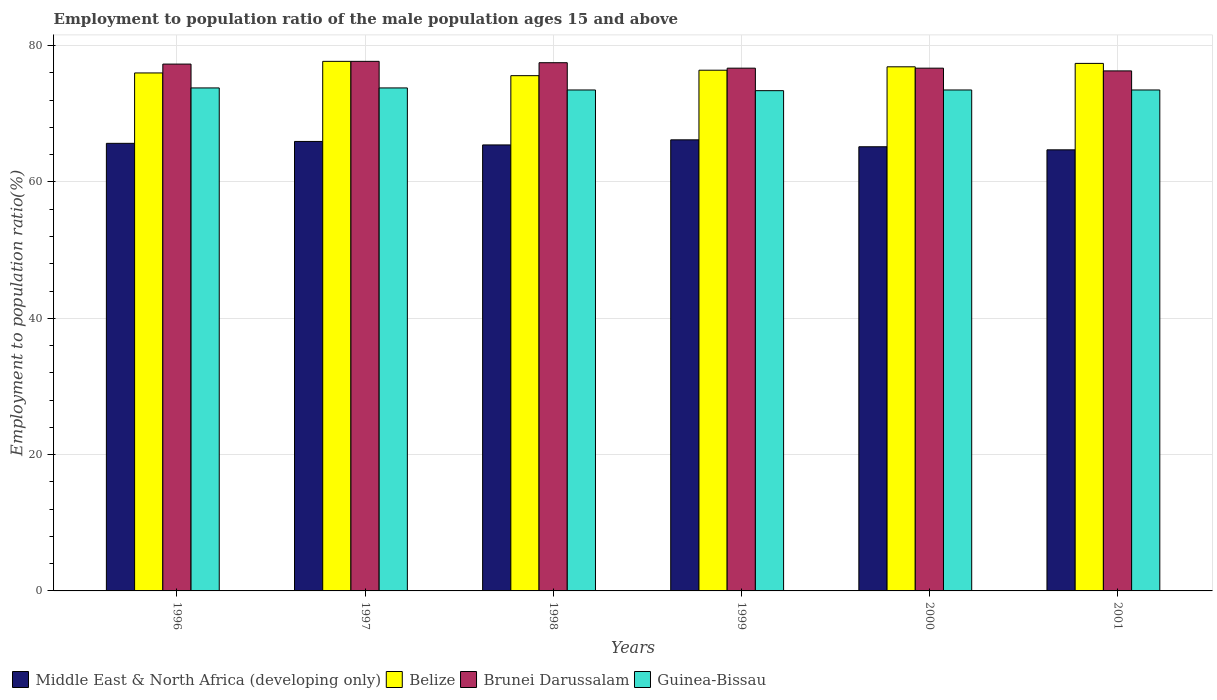How many groups of bars are there?
Keep it short and to the point. 6. How many bars are there on the 1st tick from the left?
Give a very brief answer. 4. In how many cases, is the number of bars for a given year not equal to the number of legend labels?
Keep it short and to the point. 0. What is the employment to population ratio in Belize in 2000?
Your answer should be compact. 76.9. Across all years, what is the maximum employment to population ratio in Middle East & North Africa (developing only)?
Your answer should be very brief. 66.18. Across all years, what is the minimum employment to population ratio in Belize?
Your answer should be very brief. 75.6. In which year was the employment to population ratio in Middle East & North Africa (developing only) maximum?
Provide a succinct answer. 1999. What is the total employment to population ratio in Belize in the graph?
Offer a terse response. 460. What is the difference between the employment to population ratio in Brunei Darussalam in 1997 and the employment to population ratio in Guinea-Bissau in 1998?
Keep it short and to the point. 4.2. What is the average employment to population ratio in Brunei Darussalam per year?
Give a very brief answer. 77.03. In the year 2000, what is the difference between the employment to population ratio in Belize and employment to population ratio in Guinea-Bissau?
Offer a terse response. 3.4. What is the ratio of the employment to population ratio in Middle East & North Africa (developing only) in 1996 to that in 2000?
Give a very brief answer. 1.01. What is the difference between the highest and the lowest employment to population ratio in Brunei Darussalam?
Your answer should be compact. 1.4. Is the sum of the employment to population ratio in Belize in 1997 and 1998 greater than the maximum employment to population ratio in Brunei Darussalam across all years?
Make the answer very short. Yes. What does the 3rd bar from the left in 1997 represents?
Make the answer very short. Brunei Darussalam. What does the 2nd bar from the right in 1999 represents?
Provide a short and direct response. Brunei Darussalam. Is it the case that in every year, the sum of the employment to population ratio in Brunei Darussalam and employment to population ratio in Belize is greater than the employment to population ratio in Middle East & North Africa (developing only)?
Keep it short and to the point. Yes. Are all the bars in the graph horizontal?
Make the answer very short. No. What is the difference between two consecutive major ticks on the Y-axis?
Your response must be concise. 20. Are the values on the major ticks of Y-axis written in scientific E-notation?
Offer a very short reply. No. Does the graph contain grids?
Keep it short and to the point. Yes. How many legend labels are there?
Your answer should be very brief. 4. How are the legend labels stacked?
Keep it short and to the point. Horizontal. What is the title of the graph?
Offer a terse response. Employment to population ratio of the male population ages 15 and above. Does "Guatemala" appear as one of the legend labels in the graph?
Offer a terse response. No. What is the label or title of the X-axis?
Your answer should be very brief. Years. What is the label or title of the Y-axis?
Give a very brief answer. Employment to population ratio(%). What is the Employment to population ratio(%) in Middle East & North Africa (developing only) in 1996?
Ensure brevity in your answer.  65.67. What is the Employment to population ratio(%) in Belize in 1996?
Ensure brevity in your answer.  76. What is the Employment to population ratio(%) in Brunei Darussalam in 1996?
Ensure brevity in your answer.  77.3. What is the Employment to population ratio(%) of Guinea-Bissau in 1996?
Offer a very short reply. 73.8. What is the Employment to population ratio(%) of Middle East & North Africa (developing only) in 1997?
Your response must be concise. 65.95. What is the Employment to population ratio(%) of Belize in 1997?
Provide a short and direct response. 77.7. What is the Employment to population ratio(%) in Brunei Darussalam in 1997?
Provide a succinct answer. 77.7. What is the Employment to population ratio(%) in Guinea-Bissau in 1997?
Your answer should be very brief. 73.8. What is the Employment to population ratio(%) of Middle East & North Africa (developing only) in 1998?
Your answer should be very brief. 65.44. What is the Employment to population ratio(%) of Belize in 1998?
Make the answer very short. 75.6. What is the Employment to population ratio(%) in Brunei Darussalam in 1998?
Make the answer very short. 77.5. What is the Employment to population ratio(%) in Guinea-Bissau in 1998?
Your answer should be compact. 73.5. What is the Employment to population ratio(%) in Middle East & North Africa (developing only) in 1999?
Give a very brief answer. 66.18. What is the Employment to population ratio(%) in Belize in 1999?
Provide a succinct answer. 76.4. What is the Employment to population ratio(%) in Brunei Darussalam in 1999?
Provide a succinct answer. 76.7. What is the Employment to population ratio(%) of Guinea-Bissau in 1999?
Your answer should be very brief. 73.4. What is the Employment to population ratio(%) in Middle East & North Africa (developing only) in 2000?
Your answer should be very brief. 65.17. What is the Employment to population ratio(%) of Belize in 2000?
Give a very brief answer. 76.9. What is the Employment to population ratio(%) in Brunei Darussalam in 2000?
Offer a terse response. 76.7. What is the Employment to population ratio(%) in Guinea-Bissau in 2000?
Keep it short and to the point. 73.5. What is the Employment to population ratio(%) of Middle East & North Africa (developing only) in 2001?
Ensure brevity in your answer.  64.72. What is the Employment to population ratio(%) of Belize in 2001?
Your response must be concise. 77.4. What is the Employment to population ratio(%) of Brunei Darussalam in 2001?
Provide a short and direct response. 76.3. What is the Employment to population ratio(%) of Guinea-Bissau in 2001?
Your answer should be very brief. 73.5. Across all years, what is the maximum Employment to population ratio(%) of Middle East & North Africa (developing only)?
Offer a terse response. 66.18. Across all years, what is the maximum Employment to population ratio(%) in Belize?
Offer a terse response. 77.7. Across all years, what is the maximum Employment to population ratio(%) in Brunei Darussalam?
Offer a very short reply. 77.7. Across all years, what is the maximum Employment to population ratio(%) of Guinea-Bissau?
Offer a terse response. 73.8. Across all years, what is the minimum Employment to population ratio(%) of Middle East & North Africa (developing only)?
Offer a very short reply. 64.72. Across all years, what is the minimum Employment to population ratio(%) of Belize?
Offer a very short reply. 75.6. Across all years, what is the minimum Employment to population ratio(%) of Brunei Darussalam?
Make the answer very short. 76.3. Across all years, what is the minimum Employment to population ratio(%) in Guinea-Bissau?
Your answer should be compact. 73.4. What is the total Employment to population ratio(%) of Middle East & North Africa (developing only) in the graph?
Provide a succinct answer. 393.13. What is the total Employment to population ratio(%) in Belize in the graph?
Make the answer very short. 460. What is the total Employment to population ratio(%) of Brunei Darussalam in the graph?
Make the answer very short. 462.2. What is the total Employment to population ratio(%) of Guinea-Bissau in the graph?
Give a very brief answer. 441.5. What is the difference between the Employment to population ratio(%) in Middle East & North Africa (developing only) in 1996 and that in 1997?
Provide a succinct answer. -0.28. What is the difference between the Employment to population ratio(%) in Belize in 1996 and that in 1997?
Offer a terse response. -1.7. What is the difference between the Employment to population ratio(%) of Middle East & North Africa (developing only) in 1996 and that in 1998?
Your answer should be compact. 0.23. What is the difference between the Employment to population ratio(%) of Belize in 1996 and that in 1998?
Your response must be concise. 0.4. What is the difference between the Employment to population ratio(%) of Brunei Darussalam in 1996 and that in 1998?
Your answer should be very brief. -0.2. What is the difference between the Employment to population ratio(%) of Guinea-Bissau in 1996 and that in 1998?
Make the answer very short. 0.3. What is the difference between the Employment to population ratio(%) of Middle East & North Africa (developing only) in 1996 and that in 1999?
Give a very brief answer. -0.51. What is the difference between the Employment to population ratio(%) of Guinea-Bissau in 1996 and that in 1999?
Make the answer very short. 0.4. What is the difference between the Employment to population ratio(%) in Middle East & North Africa (developing only) in 1996 and that in 2000?
Offer a very short reply. 0.5. What is the difference between the Employment to population ratio(%) in Guinea-Bissau in 1996 and that in 2000?
Offer a very short reply. 0.3. What is the difference between the Employment to population ratio(%) in Middle East & North Africa (developing only) in 1996 and that in 2001?
Offer a terse response. 0.95. What is the difference between the Employment to population ratio(%) of Guinea-Bissau in 1996 and that in 2001?
Give a very brief answer. 0.3. What is the difference between the Employment to population ratio(%) of Middle East & North Africa (developing only) in 1997 and that in 1998?
Offer a terse response. 0.51. What is the difference between the Employment to population ratio(%) of Brunei Darussalam in 1997 and that in 1998?
Offer a terse response. 0.2. What is the difference between the Employment to population ratio(%) of Guinea-Bissau in 1997 and that in 1998?
Your answer should be very brief. 0.3. What is the difference between the Employment to population ratio(%) in Middle East & North Africa (developing only) in 1997 and that in 1999?
Offer a very short reply. -0.24. What is the difference between the Employment to population ratio(%) of Guinea-Bissau in 1997 and that in 1999?
Your answer should be very brief. 0.4. What is the difference between the Employment to population ratio(%) in Middle East & North Africa (developing only) in 1997 and that in 2000?
Keep it short and to the point. 0.78. What is the difference between the Employment to population ratio(%) of Guinea-Bissau in 1997 and that in 2000?
Give a very brief answer. 0.3. What is the difference between the Employment to population ratio(%) of Middle East & North Africa (developing only) in 1997 and that in 2001?
Provide a short and direct response. 1.23. What is the difference between the Employment to population ratio(%) in Guinea-Bissau in 1997 and that in 2001?
Give a very brief answer. 0.3. What is the difference between the Employment to population ratio(%) in Middle East & North Africa (developing only) in 1998 and that in 1999?
Offer a terse response. -0.75. What is the difference between the Employment to population ratio(%) of Brunei Darussalam in 1998 and that in 1999?
Offer a terse response. 0.8. What is the difference between the Employment to population ratio(%) in Middle East & North Africa (developing only) in 1998 and that in 2000?
Your answer should be very brief. 0.27. What is the difference between the Employment to population ratio(%) of Guinea-Bissau in 1998 and that in 2000?
Make the answer very short. 0. What is the difference between the Employment to population ratio(%) of Middle East & North Africa (developing only) in 1998 and that in 2001?
Provide a succinct answer. 0.72. What is the difference between the Employment to population ratio(%) in Guinea-Bissau in 1998 and that in 2001?
Offer a terse response. 0. What is the difference between the Employment to population ratio(%) in Middle East & North Africa (developing only) in 1999 and that in 2000?
Ensure brevity in your answer.  1.02. What is the difference between the Employment to population ratio(%) of Brunei Darussalam in 1999 and that in 2000?
Offer a very short reply. 0. What is the difference between the Employment to population ratio(%) of Guinea-Bissau in 1999 and that in 2000?
Give a very brief answer. -0.1. What is the difference between the Employment to population ratio(%) of Middle East & North Africa (developing only) in 1999 and that in 2001?
Provide a short and direct response. 1.47. What is the difference between the Employment to population ratio(%) in Brunei Darussalam in 1999 and that in 2001?
Provide a short and direct response. 0.4. What is the difference between the Employment to population ratio(%) in Middle East & North Africa (developing only) in 2000 and that in 2001?
Offer a very short reply. 0.45. What is the difference between the Employment to population ratio(%) of Brunei Darussalam in 2000 and that in 2001?
Your response must be concise. 0.4. What is the difference between the Employment to population ratio(%) of Guinea-Bissau in 2000 and that in 2001?
Offer a very short reply. 0. What is the difference between the Employment to population ratio(%) in Middle East & North Africa (developing only) in 1996 and the Employment to population ratio(%) in Belize in 1997?
Provide a short and direct response. -12.03. What is the difference between the Employment to population ratio(%) in Middle East & North Africa (developing only) in 1996 and the Employment to population ratio(%) in Brunei Darussalam in 1997?
Offer a very short reply. -12.03. What is the difference between the Employment to population ratio(%) of Middle East & North Africa (developing only) in 1996 and the Employment to population ratio(%) of Guinea-Bissau in 1997?
Make the answer very short. -8.13. What is the difference between the Employment to population ratio(%) of Brunei Darussalam in 1996 and the Employment to population ratio(%) of Guinea-Bissau in 1997?
Ensure brevity in your answer.  3.5. What is the difference between the Employment to population ratio(%) in Middle East & North Africa (developing only) in 1996 and the Employment to population ratio(%) in Belize in 1998?
Offer a very short reply. -9.93. What is the difference between the Employment to population ratio(%) of Middle East & North Africa (developing only) in 1996 and the Employment to population ratio(%) of Brunei Darussalam in 1998?
Your answer should be very brief. -11.83. What is the difference between the Employment to population ratio(%) in Middle East & North Africa (developing only) in 1996 and the Employment to population ratio(%) in Guinea-Bissau in 1998?
Provide a succinct answer. -7.83. What is the difference between the Employment to population ratio(%) of Belize in 1996 and the Employment to population ratio(%) of Guinea-Bissau in 1998?
Offer a terse response. 2.5. What is the difference between the Employment to population ratio(%) of Brunei Darussalam in 1996 and the Employment to population ratio(%) of Guinea-Bissau in 1998?
Ensure brevity in your answer.  3.8. What is the difference between the Employment to population ratio(%) of Middle East & North Africa (developing only) in 1996 and the Employment to population ratio(%) of Belize in 1999?
Ensure brevity in your answer.  -10.73. What is the difference between the Employment to population ratio(%) of Middle East & North Africa (developing only) in 1996 and the Employment to population ratio(%) of Brunei Darussalam in 1999?
Give a very brief answer. -11.03. What is the difference between the Employment to population ratio(%) of Middle East & North Africa (developing only) in 1996 and the Employment to population ratio(%) of Guinea-Bissau in 1999?
Ensure brevity in your answer.  -7.73. What is the difference between the Employment to population ratio(%) of Belize in 1996 and the Employment to population ratio(%) of Brunei Darussalam in 1999?
Make the answer very short. -0.7. What is the difference between the Employment to population ratio(%) in Belize in 1996 and the Employment to population ratio(%) in Guinea-Bissau in 1999?
Give a very brief answer. 2.6. What is the difference between the Employment to population ratio(%) of Brunei Darussalam in 1996 and the Employment to population ratio(%) of Guinea-Bissau in 1999?
Ensure brevity in your answer.  3.9. What is the difference between the Employment to population ratio(%) in Middle East & North Africa (developing only) in 1996 and the Employment to population ratio(%) in Belize in 2000?
Give a very brief answer. -11.23. What is the difference between the Employment to population ratio(%) of Middle East & North Africa (developing only) in 1996 and the Employment to population ratio(%) of Brunei Darussalam in 2000?
Your answer should be very brief. -11.03. What is the difference between the Employment to population ratio(%) in Middle East & North Africa (developing only) in 1996 and the Employment to population ratio(%) in Guinea-Bissau in 2000?
Make the answer very short. -7.83. What is the difference between the Employment to population ratio(%) in Belize in 1996 and the Employment to population ratio(%) in Guinea-Bissau in 2000?
Your response must be concise. 2.5. What is the difference between the Employment to population ratio(%) in Middle East & North Africa (developing only) in 1996 and the Employment to population ratio(%) in Belize in 2001?
Offer a very short reply. -11.73. What is the difference between the Employment to population ratio(%) of Middle East & North Africa (developing only) in 1996 and the Employment to population ratio(%) of Brunei Darussalam in 2001?
Ensure brevity in your answer.  -10.63. What is the difference between the Employment to population ratio(%) in Middle East & North Africa (developing only) in 1996 and the Employment to population ratio(%) in Guinea-Bissau in 2001?
Provide a succinct answer. -7.83. What is the difference between the Employment to population ratio(%) in Belize in 1996 and the Employment to population ratio(%) in Guinea-Bissau in 2001?
Offer a terse response. 2.5. What is the difference between the Employment to population ratio(%) in Middle East & North Africa (developing only) in 1997 and the Employment to population ratio(%) in Belize in 1998?
Ensure brevity in your answer.  -9.65. What is the difference between the Employment to population ratio(%) in Middle East & North Africa (developing only) in 1997 and the Employment to population ratio(%) in Brunei Darussalam in 1998?
Your answer should be compact. -11.55. What is the difference between the Employment to population ratio(%) of Middle East & North Africa (developing only) in 1997 and the Employment to population ratio(%) of Guinea-Bissau in 1998?
Provide a short and direct response. -7.55. What is the difference between the Employment to population ratio(%) in Belize in 1997 and the Employment to population ratio(%) in Brunei Darussalam in 1998?
Provide a succinct answer. 0.2. What is the difference between the Employment to population ratio(%) of Brunei Darussalam in 1997 and the Employment to population ratio(%) of Guinea-Bissau in 1998?
Ensure brevity in your answer.  4.2. What is the difference between the Employment to population ratio(%) of Middle East & North Africa (developing only) in 1997 and the Employment to population ratio(%) of Belize in 1999?
Make the answer very short. -10.45. What is the difference between the Employment to population ratio(%) in Middle East & North Africa (developing only) in 1997 and the Employment to population ratio(%) in Brunei Darussalam in 1999?
Your response must be concise. -10.75. What is the difference between the Employment to population ratio(%) of Middle East & North Africa (developing only) in 1997 and the Employment to population ratio(%) of Guinea-Bissau in 1999?
Provide a short and direct response. -7.45. What is the difference between the Employment to population ratio(%) in Brunei Darussalam in 1997 and the Employment to population ratio(%) in Guinea-Bissau in 1999?
Keep it short and to the point. 4.3. What is the difference between the Employment to population ratio(%) in Middle East & North Africa (developing only) in 1997 and the Employment to population ratio(%) in Belize in 2000?
Keep it short and to the point. -10.95. What is the difference between the Employment to population ratio(%) in Middle East & North Africa (developing only) in 1997 and the Employment to population ratio(%) in Brunei Darussalam in 2000?
Provide a short and direct response. -10.75. What is the difference between the Employment to population ratio(%) in Middle East & North Africa (developing only) in 1997 and the Employment to population ratio(%) in Guinea-Bissau in 2000?
Keep it short and to the point. -7.55. What is the difference between the Employment to population ratio(%) in Belize in 1997 and the Employment to population ratio(%) in Brunei Darussalam in 2000?
Provide a short and direct response. 1. What is the difference between the Employment to population ratio(%) in Middle East & North Africa (developing only) in 1997 and the Employment to population ratio(%) in Belize in 2001?
Keep it short and to the point. -11.45. What is the difference between the Employment to population ratio(%) of Middle East & North Africa (developing only) in 1997 and the Employment to population ratio(%) of Brunei Darussalam in 2001?
Your answer should be very brief. -10.35. What is the difference between the Employment to population ratio(%) in Middle East & North Africa (developing only) in 1997 and the Employment to population ratio(%) in Guinea-Bissau in 2001?
Provide a short and direct response. -7.55. What is the difference between the Employment to population ratio(%) in Belize in 1997 and the Employment to population ratio(%) in Guinea-Bissau in 2001?
Your answer should be very brief. 4.2. What is the difference between the Employment to population ratio(%) of Middle East & North Africa (developing only) in 1998 and the Employment to population ratio(%) of Belize in 1999?
Your answer should be very brief. -10.96. What is the difference between the Employment to population ratio(%) in Middle East & North Africa (developing only) in 1998 and the Employment to population ratio(%) in Brunei Darussalam in 1999?
Provide a succinct answer. -11.26. What is the difference between the Employment to population ratio(%) of Middle East & North Africa (developing only) in 1998 and the Employment to population ratio(%) of Guinea-Bissau in 1999?
Provide a succinct answer. -7.96. What is the difference between the Employment to population ratio(%) of Belize in 1998 and the Employment to population ratio(%) of Guinea-Bissau in 1999?
Offer a terse response. 2.2. What is the difference between the Employment to population ratio(%) in Brunei Darussalam in 1998 and the Employment to population ratio(%) in Guinea-Bissau in 1999?
Offer a terse response. 4.1. What is the difference between the Employment to population ratio(%) of Middle East & North Africa (developing only) in 1998 and the Employment to population ratio(%) of Belize in 2000?
Offer a terse response. -11.46. What is the difference between the Employment to population ratio(%) in Middle East & North Africa (developing only) in 1998 and the Employment to population ratio(%) in Brunei Darussalam in 2000?
Offer a very short reply. -11.26. What is the difference between the Employment to population ratio(%) in Middle East & North Africa (developing only) in 1998 and the Employment to population ratio(%) in Guinea-Bissau in 2000?
Your answer should be very brief. -8.06. What is the difference between the Employment to population ratio(%) in Belize in 1998 and the Employment to population ratio(%) in Brunei Darussalam in 2000?
Make the answer very short. -1.1. What is the difference between the Employment to population ratio(%) in Belize in 1998 and the Employment to population ratio(%) in Guinea-Bissau in 2000?
Your response must be concise. 2.1. What is the difference between the Employment to population ratio(%) in Middle East & North Africa (developing only) in 1998 and the Employment to population ratio(%) in Belize in 2001?
Provide a succinct answer. -11.96. What is the difference between the Employment to population ratio(%) of Middle East & North Africa (developing only) in 1998 and the Employment to population ratio(%) of Brunei Darussalam in 2001?
Make the answer very short. -10.86. What is the difference between the Employment to population ratio(%) in Middle East & North Africa (developing only) in 1998 and the Employment to population ratio(%) in Guinea-Bissau in 2001?
Make the answer very short. -8.06. What is the difference between the Employment to population ratio(%) in Belize in 1998 and the Employment to population ratio(%) in Guinea-Bissau in 2001?
Provide a succinct answer. 2.1. What is the difference between the Employment to population ratio(%) of Middle East & North Africa (developing only) in 1999 and the Employment to population ratio(%) of Belize in 2000?
Your answer should be very brief. -10.72. What is the difference between the Employment to population ratio(%) of Middle East & North Africa (developing only) in 1999 and the Employment to population ratio(%) of Brunei Darussalam in 2000?
Keep it short and to the point. -10.52. What is the difference between the Employment to population ratio(%) in Middle East & North Africa (developing only) in 1999 and the Employment to population ratio(%) in Guinea-Bissau in 2000?
Make the answer very short. -7.32. What is the difference between the Employment to population ratio(%) of Belize in 1999 and the Employment to population ratio(%) of Brunei Darussalam in 2000?
Your answer should be compact. -0.3. What is the difference between the Employment to population ratio(%) in Belize in 1999 and the Employment to population ratio(%) in Guinea-Bissau in 2000?
Offer a terse response. 2.9. What is the difference between the Employment to population ratio(%) in Middle East & North Africa (developing only) in 1999 and the Employment to population ratio(%) in Belize in 2001?
Offer a very short reply. -11.22. What is the difference between the Employment to population ratio(%) in Middle East & North Africa (developing only) in 1999 and the Employment to population ratio(%) in Brunei Darussalam in 2001?
Provide a succinct answer. -10.12. What is the difference between the Employment to population ratio(%) of Middle East & North Africa (developing only) in 1999 and the Employment to population ratio(%) of Guinea-Bissau in 2001?
Your answer should be very brief. -7.32. What is the difference between the Employment to population ratio(%) of Belize in 1999 and the Employment to population ratio(%) of Brunei Darussalam in 2001?
Make the answer very short. 0.1. What is the difference between the Employment to population ratio(%) of Brunei Darussalam in 1999 and the Employment to population ratio(%) of Guinea-Bissau in 2001?
Your answer should be compact. 3.2. What is the difference between the Employment to population ratio(%) of Middle East & North Africa (developing only) in 2000 and the Employment to population ratio(%) of Belize in 2001?
Your answer should be very brief. -12.23. What is the difference between the Employment to population ratio(%) of Middle East & North Africa (developing only) in 2000 and the Employment to population ratio(%) of Brunei Darussalam in 2001?
Offer a very short reply. -11.13. What is the difference between the Employment to population ratio(%) of Middle East & North Africa (developing only) in 2000 and the Employment to population ratio(%) of Guinea-Bissau in 2001?
Your response must be concise. -8.33. What is the difference between the Employment to population ratio(%) of Belize in 2000 and the Employment to population ratio(%) of Brunei Darussalam in 2001?
Ensure brevity in your answer.  0.6. What is the difference between the Employment to population ratio(%) in Brunei Darussalam in 2000 and the Employment to population ratio(%) in Guinea-Bissau in 2001?
Provide a short and direct response. 3.2. What is the average Employment to population ratio(%) of Middle East & North Africa (developing only) per year?
Offer a very short reply. 65.52. What is the average Employment to population ratio(%) of Belize per year?
Provide a succinct answer. 76.67. What is the average Employment to population ratio(%) of Brunei Darussalam per year?
Make the answer very short. 77.03. What is the average Employment to population ratio(%) of Guinea-Bissau per year?
Your answer should be compact. 73.58. In the year 1996, what is the difference between the Employment to population ratio(%) in Middle East & North Africa (developing only) and Employment to population ratio(%) in Belize?
Give a very brief answer. -10.33. In the year 1996, what is the difference between the Employment to population ratio(%) of Middle East & North Africa (developing only) and Employment to population ratio(%) of Brunei Darussalam?
Your answer should be compact. -11.63. In the year 1996, what is the difference between the Employment to population ratio(%) in Middle East & North Africa (developing only) and Employment to population ratio(%) in Guinea-Bissau?
Give a very brief answer. -8.13. In the year 1997, what is the difference between the Employment to population ratio(%) of Middle East & North Africa (developing only) and Employment to population ratio(%) of Belize?
Your answer should be compact. -11.75. In the year 1997, what is the difference between the Employment to population ratio(%) in Middle East & North Africa (developing only) and Employment to population ratio(%) in Brunei Darussalam?
Provide a short and direct response. -11.75. In the year 1997, what is the difference between the Employment to population ratio(%) of Middle East & North Africa (developing only) and Employment to population ratio(%) of Guinea-Bissau?
Make the answer very short. -7.85. In the year 1997, what is the difference between the Employment to population ratio(%) in Belize and Employment to population ratio(%) in Brunei Darussalam?
Provide a succinct answer. 0. In the year 1997, what is the difference between the Employment to population ratio(%) of Belize and Employment to population ratio(%) of Guinea-Bissau?
Keep it short and to the point. 3.9. In the year 1998, what is the difference between the Employment to population ratio(%) in Middle East & North Africa (developing only) and Employment to population ratio(%) in Belize?
Provide a short and direct response. -10.16. In the year 1998, what is the difference between the Employment to population ratio(%) in Middle East & North Africa (developing only) and Employment to population ratio(%) in Brunei Darussalam?
Offer a very short reply. -12.06. In the year 1998, what is the difference between the Employment to population ratio(%) of Middle East & North Africa (developing only) and Employment to population ratio(%) of Guinea-Bissau?
Your answer should be compact. -8.06. In the year 1998, what is the difference between the Employment to population ratio(%) in Belize and Employment to population ratio(%) in Guinea-Bissau?
Provide a succinct answer. 2.1. In the year 1998, what is the difference between the Employment to population ratio(%) in Brunei Darussalam and Employment to population ratio(%) in Guinea-Bissau?
Keep it short and to the point. 4. In the year 1999, what is the difference between the Employment to population ratio(%) of Middle East & North Africa (developing only) and Employment to population ratio(%) of Belize?
Provide a short and direct response. -10.22. In the year 1999, what is the difference between the Employment to population ratio(%) of Middle East & North Africa (developing only) and Employment to population ratio(%) of Brunei Darussalam?
Offer a very short reply. -10.52. In the year 1999, what is the difference between the Employment to population ratio(%) of Middle East & North Africa (developing only) and Employment to population ratio(%) of Guinea-Bissau?
Ensure brevity in your answer.  -7.22. In the year 1999, what is the difference between the Employment to population ratio(%) in Belize and Employment to population ratio(%) in Guinea-Bissau?
Offer a very short reply. 3. In the year 2000, what is the difference between the Employment to population ratio(%) of Middle East & North Africa (developing only) and Employment to population ratio(%) of Belize?
Your response must be concise. -11.73. In the year 2000, what is the difference between the Employment to population ratio(%) in Middle East & North Africa (developing only) and Employment to population ratio(%) in Brunei Darussalam?
Give a very brief answer. -11.53. In the year 2000, what is the difference between the Employment to population ratio(%) in Middle East & North Africa (developing only) and Employment to population ratio(%) in Guinea-Bissau?
Make the answer very short. -8.33. In the year 2000, what is the difference between the Employment to population ratio(%) in Belize and Employment to population ratio(%) in Brunei Darussalam?
Keep it short and to the point. 0.2. In the year 2000, what is the difference between the Employment to population ratio(%) in Brunei Darussalam and Employment to population ratio(%) in Guinea-Bissau?
Keep it short and to the point. 3.2. In the year 2001, what is the difference between the Employment to population ratio(%) in Middle East & North Africa (developing only) and Employment to population ratio(%) in Belize?
Offer a very short reply. -12.68. In the year 2001, what is the difference between the Employment to population ratio(%) in Middle East & North Africa (developing only) and Employment to population ratio(%) in Brunei Darussalam?
Make the answer very short. -11.58. In the year 2001, what is the difference between the Employment to population ratio(%) in Middle East & North Africa (developing only) and Employment to population ratio(%) in Guinea-Bissau?
Offer a very short reply. -8.78. In the year 2001, what is the difference between the Employment to population ratio(%) in Belize and Employment to population ratio(%) in Brunei Darussalam?
Keep it short and to the point. 1.1. In the year 2001, what is the difference between the Employment to population ratio(%) in Belize and Employment to population ratio(%) in Guinea-Bissau?
Ensure brevity in your answer.  3.9. In the year 2001, what is the difference between the Employment to population ratio(%) of Brunei Darussalam and Employment to population ratio(%) of Guinea-Bissau?
Your answer should be very brief. 2.8. What is the ratio of the Employment to population ratio(%) of Belize in 1996 to that in 1997?
Your response must be concise. 0.98. What is the ratio of the Employment to population ratio(%) in Brunei Darussalam in 1996 to that in 1997?
Offer a terse response. 0.99. What is the ratio of the Employment to population ratio(%) of Belize in 1996 to that in 1999?
Make the answer very short. 0.99. What is the ratio of the Employment to population ratio(%) in Brunei Darussalam in 1996 to that in 1999?
Offer a terse response. 1.01. What is the ratio of the Employment to population ratio(%) in Guinea-Bissau in 1996 to that in 1999?
Your answer should be very brief. 1.01. What is the ratio of the Employment to population ratio(%) of Middle East & North Africa (developing only) in 1996 to that in 2000?
Offer a very short reply. 1.01. What is the ratio of the Employment to population ratio(%) in Belize in 1996 to that in 2000?
Ensure brevity in your answer.  0.99. What is the ratio of the Employment to population ratio(%) in Guinea-Bissau in 1996 to that in 2000?
Provide a short and direct response. 1. What is the ratio of the Employment to population ratio(%) of Middle East & North Africa (developing only) in 1996 to that in 2001?
Your answer should be very brief. 1.01. What is the ratio of the Employment to population ratio(%) of Belize in 1996 to that in 2001?
Provide a succinct answer. 0.98. What is the ratio of the Employment to population ratio(%) of Brunei Darussalam in 1996 to that in 2001?
Your answer should be compact. 1.01. What is the ratio of the Employment to population ratio(%) of Guinea-Bissau in 1996 to that in 2001?
Ensure brevity in your answer.  1. What is the ratio of the Employment to population ratio(%) in Middle East & North Africa (developing only) in 1997 to that in 1998?
Ensure brevity in your answer.  1.01. What is the ratio of the Employment to population ratio(%) in Belize in 1997 to that in 1998?
Provide a succinct answer. 1.03. What is the ratio of the Employment to population ratio(%) in Brunei Darussalam in 1997 to that in 1998?
Make the answer very short. 1. What is the ratio of the Employment to population ratio(%) of Middle East & North Africa (developing only) in 1997 to that in 1999?
Ensure brevity in your answer.  1. What is the ratio of the Employment to population ratio(%) of Guinea-Bissau in 1997 to that in 1999?
Your answer should be very brief. 1.01. What is the ratio of the Employment to population ratio(%) in Belize in 1997 to that in 2000?
Ensure brevity in your answer.  1.01. What is the ratio of the Employment to population ratio(%) in Brunei Darussalam in 1997 to that in 2000?
Ensure brevity in your answer.  1.01. What is the ratio of the Employment to population ratio(%) of Belize in 1997 to that in 2001?
Your response must be concise. 1. What is the ratio of the Employment to population ratio(%) of Brunei Darussalam in 1997 to that in 2001?
Your response must be concise. 1.02. What is the ratio of the Employment to population ratio(%) of Guinea-Bissau in 1997 to that in 2001?
Give a very brief answer. 1. What is the ratio of the Employment to population ratio(%) of Middle East & North Africa (developing only) in 1998 to that in 1999?
Your answer should be very brief. 0.99. What is the ratio of the Employment to population ratio(%) in Brunei Darussalam in 1998 to that in 1999?
Make the answer very short. 1.01. What is the ratio of the Employment to population ratio(%) in Belize in 1998 to that in 2000?
Provide a short and direct response. 0.98. What is the ratio of the Employment to population ratio(%) of Brunei Darussalam in 1998 to that in 2000?
Provide a succinct answer. 1.01. What is the ratio of the Employment to population ratio(%) of Middle East & North Africa (developing only) in 1998 to that in 2001?
Give a very brief answer. 1.01. What is the ratio of the Employment to population ratio(%) of Belize in 1998 to that in 2001?
Your answer should be compact. 0.98. What is the ratio of the Employment to population ratio(%) of Brunei Darussalam in 1998 to that in 2001?
Offer a terse response. 1.02. What is the ratio of the Employment to population ratio(%) of Guinea-Bissau in 1998 to that in 2001?
Ensure brevity in your answer.  1. What is the ratio of the Employment to population ratio(%) of Middle East & North Africa (developing only) in 1999 to that in 2000?
Your answer should be compact. 1.02. What is the ratio of the Employment to population ratio(%) of Belize in 1999 to that in 2000?
Keep it short and to the point. 0.99. What is the ratio of the Employment to population ratio(%) in Brunei Darussalam in 1999 to that in 2000?
Provide a succinct answer. 1. What is the ratio of the Employment to population ratio(%) of Guinea-Bissau in 1999 to that in 2000?
Give a very brief answer. 1. What is the ratio of the Employment to population ratio(%) of Middle East & North Africa (developing only) in 1999 to that in 2001?
Make the answer very short. 1.02. What is the ratio of the Employment to population ratio(%) in Belize in 1999 to that in 2001?
Offer a terse response. 0.99. What is the ratio of the Employment to population ratio(%) of Brunei Darussalam in 1999 to that in 2001?
Provide a short and direct response. 1.01. What is the ratio of the Employment to population ratio(%) of Belize in 2000 to that in 2001?
Offer a terse response. 0.99. What is the ratio of the Employment to population ratio(%) of Guinea-Bissau in 2000 to that in 2001?
Your answer should be compact. 1. What is the difference between the highest and the second highest Employment to population ratio(%) in Middle East & North Africa (developing only)?
Your response must be concise. 0.24. What is the difference between the highest and the second highest Employment to population ratio(%) of Guinea-Bissau?
Your answer should be very brief. 0. What is the difference between the highest and the lowest Employment to population ratio(%) in Middle East & North Africa (developing only)?
Ensure brevity in your answer.  1.47. What is the difference between the highest and the lowest Employment to population ratio(%) of Belize?
Make the answer very short. 2.1. What is the difference between the highest and the lowest Employment to population ratio(%) in Brunei Darussalam?
Offer a terse response. 1.4. 